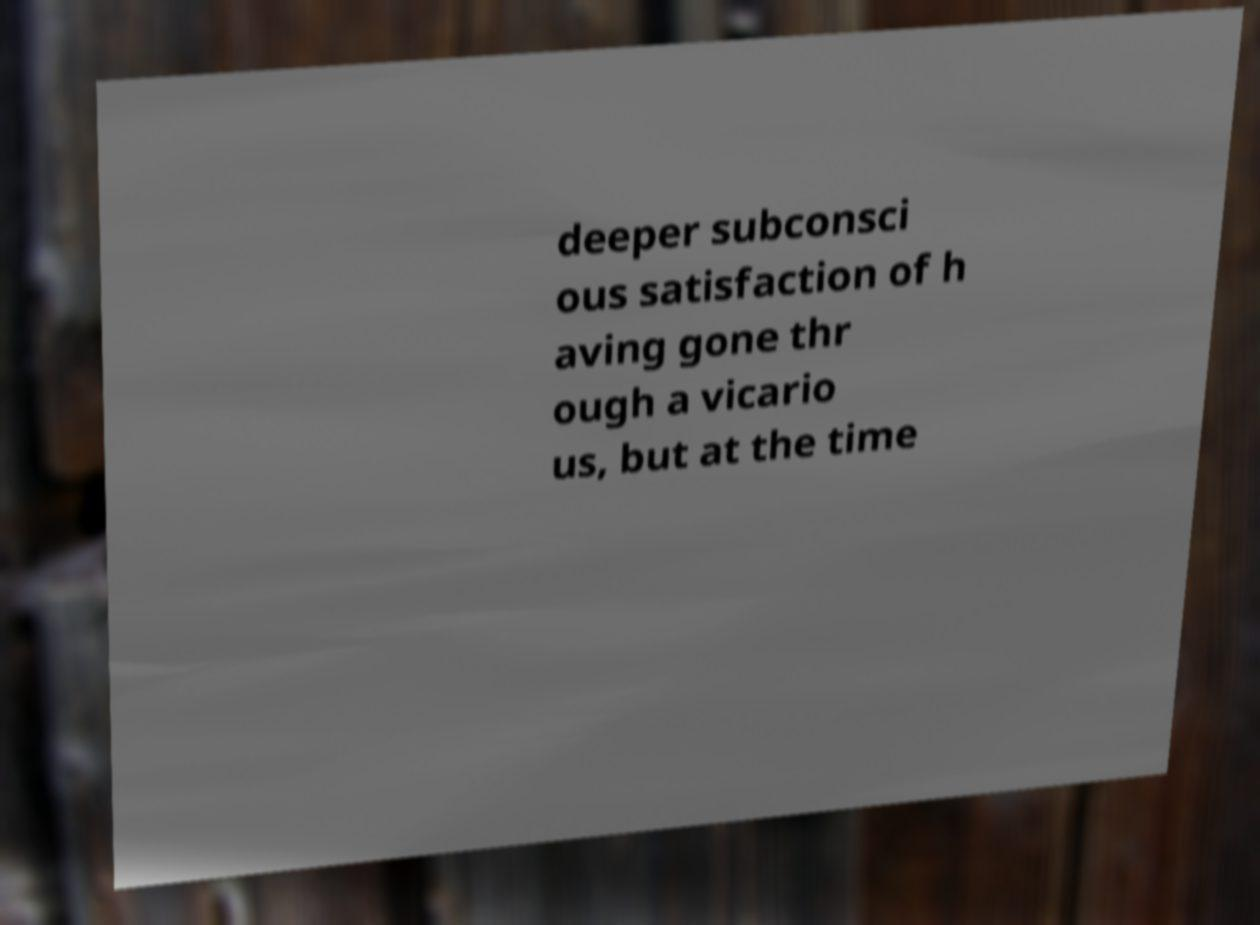Can you read and provide the text displayed in the image?This photo seems to have some interesting text. Can you extract and type it out for me? deeper subconsci ous satisfaction of h aving gone thr ough a vicario us, but at the time 